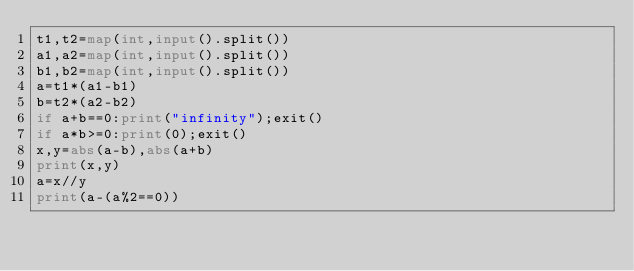Convert code to text. <code><loc_0><loc_0><loc_500><loc_500><_Python_>t1,t2=map(int,input().split())
a1,a2=map(int,input().split())
b1,b2=map(int,input().split())
a=t1*(a1-b1)
b=t2*(a2-b2)
if a+b==0:print("infinity");exit()
if a*b>=0:print(0);exit()
x,y=abs(a-b),abs(a+b)
print(x,y)
a=x//y
print(a-(a%2==0))</code> 